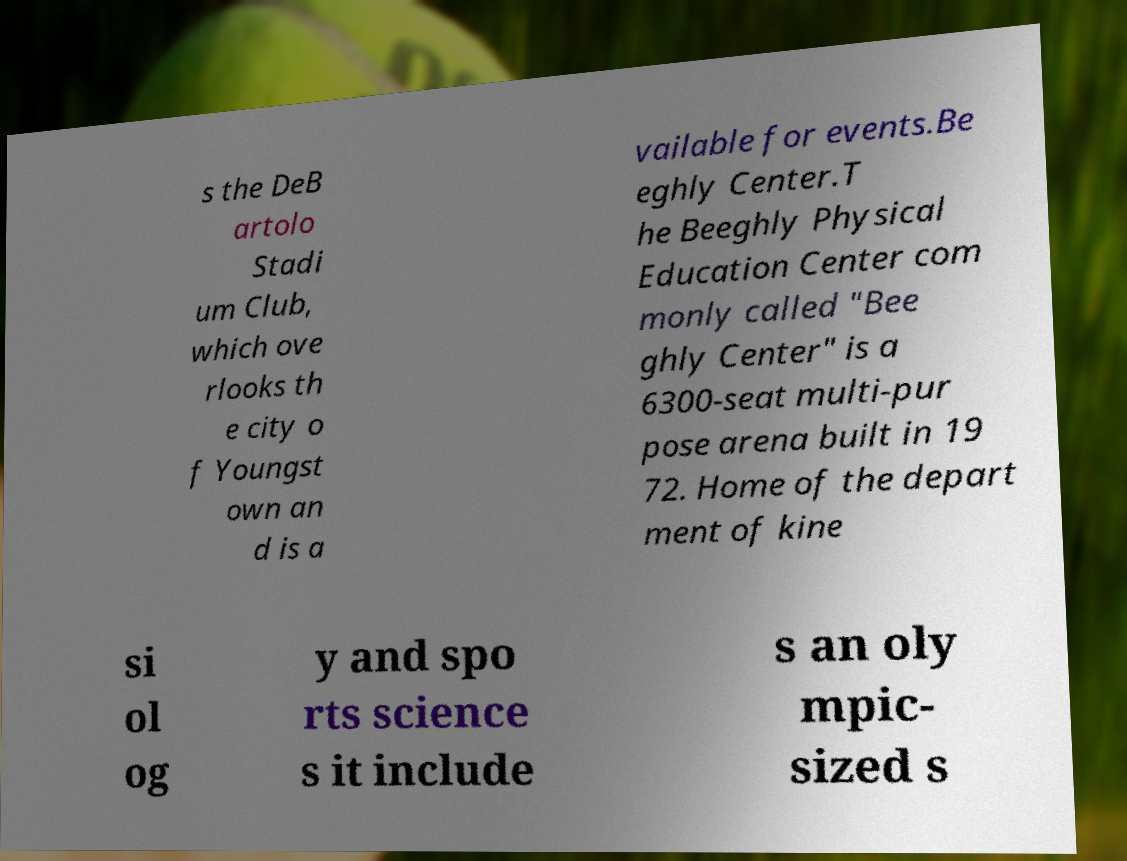Could you extract and type out the text from this image? s the DeB artolo Stadi um Club, which ove rlooks th e city o f Youngst own an d is a vailable for events.Be eghly Center.T he Beeghly Physical Education Center com monly called "Bee ghly Center" is a 6300-seat multi-pur pose arena built in 19 72. Home of the depart ment of kine si ol og y and spo rts science s it include s an oly mpic- sized s 